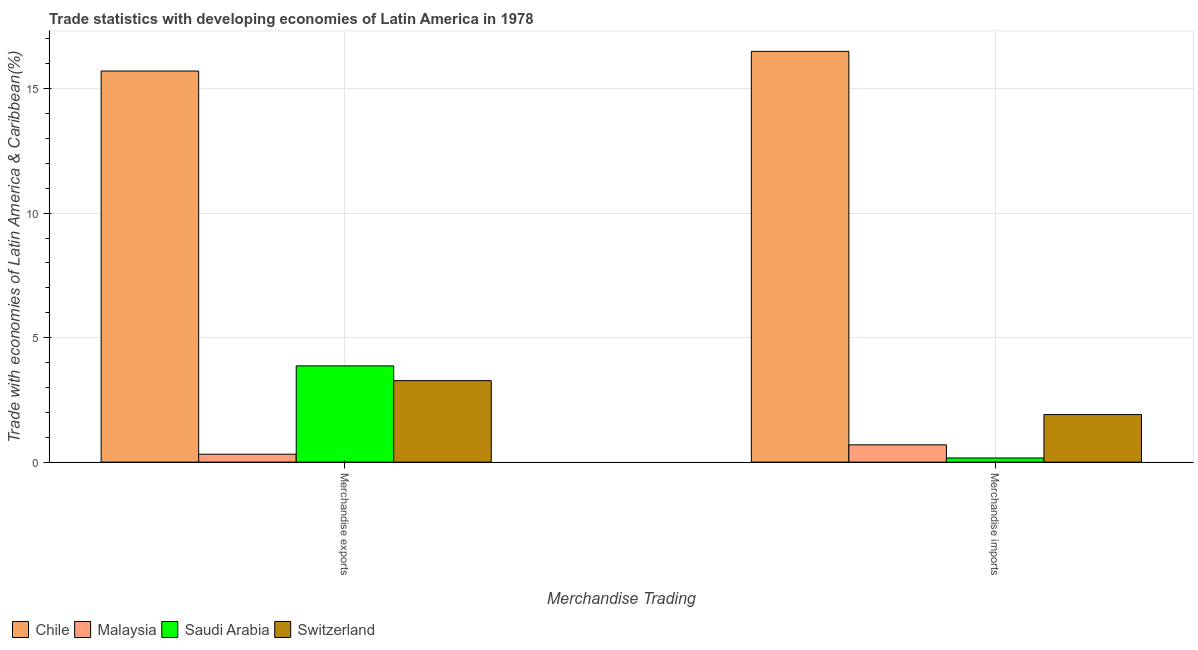How many groups of bars are there?
Your response must be concise. 2. Are the number of bars on each tick of the X-axis equal?
Give a very brief answer. Yes. What is the label of the 1st group of bars from the left?
Your response must be concise. Merchandise exports. What is the merchandise imports in Switzerland?
Offer a very short reply. 1.91. Across all countries, what is the maximum merchandise exports?
Your response must be concise. 15.71. Across all countries, what is the minimum merchandise imports?
Offer a very short reply. 0.17. In which country was the merchandise exports maximum?
Offer a terse response. Chile. In which country was the merchandise imports minimum?
Your answer should be compact. Saudi Arabia. What is the total merchandise exports in the graph?
Ensure brevity in your answer.  23.16. What is the difference between the merchandise imports in Malaysia and that in Saudi Arabia?
Offer a terse response. 0.53. What is the difference between the merchandise exports in Saudi Arabia and the merchandise imports in Switzerland?
Offer a terse response. 1.96. What is the average merchandise exports per country?
Provide a short and direct response. 5.79. What is the difference between the merchandise exports and merchandise imports in Saudi Arabia?
Give a very brief answer. 3.7. In how many countries, is the merchandise imports greater than 10 %?
Keep it short and to the point. 1. What is the ratio of the merchandise imports in Malaysia to that in Switzerland?
Keep it short and to the point. 0.36. In how many countries, is the merchandise exports greater than the average merchandise exports taken over all countries?
Ensure brevity in your answer.  1. What does the 4th bar from the left in Merchandise exports represents?
Make the answer very short. Switzerland. What does the 1st bar from the right in Merchandise imports represents?
Your answer should be very brief. Switzerland. How many bars are there?
Your answer should be compact. 8. Are all the bars in the graph horizontal?
Give a very brief answer. No. Where does the legend appear in the graph?
Offer a terse response. Bottom left. How many legend labels are there?
Ensure brevity in your answer.  4. How are the legend labels stacked?
Keep it short and to the point. Horizontal. What is the title of the graph?
Provide a short and direct response. Trade statistics with developing economies of Latin America in 1978. Does "Seychelles" appear as one of the legend labels in the graph?
Keep it short and to the point. No. What is the label or title of the X-axis?
Your answer should be compact. Merchandise Trading. What is the label or title of the Y-axis?
Make the answer very short. Trade with economies of Latin America & Caribbean(%). What is the Trade with economies of Latin America & Caribbean(%) in Chile in Merchandise exports?
Provide a short and direct response. 15.71. What is the Trade with economies of Latin America & Caribbean(%) in Malaysia in Merchandise exports?
Provide a succinct answer. 0.32. What is the Trade with economies of Latin America & Caribbean(%) in Saudi Arabia in Merchandise exports?
Ensure brevity in your answer.  3.87. What is the Trade with economies of Latin America & Caribbean(%) of Switzerland in Merchandise exports?
Offer a very short reply. 3.27. What is the Trade with economies of Latin America & Caribbean(%) in Chile in Merchandise imports?
Provide a succinct answer. 16.5. What is the Trade with economies of Latin America & Caribbean(%) in Malaysia in Merchandise imports?
Provide a succinct answer. 0.69. What is the Trade with economies of Latin America & Caribbean(%) of Saudi Arabia in Merchandise imports?
Your answer should be compact. 0.17. What is the Trade with economies of Latin America & Caribbean(%) of Switzerland in Merchandise imports?
Provide a succinct answer. 1.91. Across all Merchandise Trading, what is the maximum Trade with economies of Latin America & Caribbean(%) of Chile?
Provide a short and direct response. 16.5. Across all Merchandise Trading, what is the maximum Trade with economies of Latin America & Caribbean(%) in Malaysia?
Make the answer very short. 0.69. Across all Merchandise Trading, what is the maximum Trade with economies of Latin America & Caribbean(%) in Saudi Arabia?
Provide a succinct answer. 3.87. Across all Merchandise Trading, what is the maximum Trade with economies of Latin America & Caribbean(%) in Switzerland?
Offer a very short reply. 3.27. Across all Merchandise Trading, what is the minimum Trade with economies of Latin America & Caribbean(%) of Chile?
Ensure brevity in your answer.  15.71. Across all Merchandise Trading, what is the minimum Trade with economies of Latin America & Caribbean(%) in Malaysia?
Keep it short and to the point. 0.32. Across all Merchandise Trading, what is the minimum Trade with economies of Latin America & Caribbean(%) in Saudi Arabia?
Your answer should be very brief. 0.17. Across all Merchandise Trading, what is the minimum Trade with economies of Latin America & Caribbean(%) of Switzerland?
Ensure brevity in your answer.  1.91. What is the total Trade with economies of Latin America & Caribbean(%) of Chile in the graph?
Offer a very short reply. 32.2. What is the total Trade with economies of Latin America & Caribbean(%) of Malaysia in the graph?
Offer a very short reply. 1.01. What is the total Trade with economies of Latin America & Caribbean(%) in Saudi Arabia in the graph?
Provide a short and direct response. 4.03. What is the total Trade with economies of Latin America & Caribbean(%) in Switzerland in the graph?
Offer a terse response. 5.18. What is the difference between the Trade with economies of Latin America & Caribbean(%) in Chile in Merchandise exports and that in Merchandise imports?
Ensure brevity in your answer.  -0.79. What is the difference between the Trade with economies of Latin America & Caribbean(%) of Malaysia in Merchandise exports and that in Merchandise imports?
Offer a very short reply. -0.38. What is the difference between the Trade with economies of Latin America & Caribbean(%) of Saudi Arabia in Merchandise exports and that in Merchandise imports?
Provide a succinct answer. 3.7. What is the difference between the Trade with economies of Latin America & Caribbean(%) in Switzerland in Merchandise exports and that in Merchandise imports?
Provide a short and direct response. 1.36. What is the difference between the Trade with economies of Latin America & Caribbean(%) in Chile in Merchandise exports and the Trade with economies of Latin America & Caribbean(%) in Malaysia in Merchandise imports?
Provide a succinct answer. 15.01. What is the difference between the Trade with economies of Latin America & Caribbean(%) in Chile in Merchandise exports and the Trade with economies of Latin America & Caribbean(%) in Saudi Arabia in Merchandise imports?
Give a very brief answer. 15.54. What is the difference between the Trade with economies of Latin America & Caribbean(%) of Chile in Merchandise exports and the Trade with economies of Latin America & Caribbean(%) of Switzerland in Merchandise imports?
Your response must be concise. 13.8. What is the difference between the Trade with economies of Latin America & Caribbean(%) of Malaysia in Merchandise exports and the Trade with economies of Latin America & Caribbean(%) of Saudi Arabia in Merchandise imports?
Your response must be concise. 0.15. What is the difference between the Trade with economies of Latin America & Caribbean(%) in Malaysia in Merchandise exports and the Trade with economies of Latin America & Caribbean(%) in Switzerland in Merchandise imports?
Give a very brief answer. -1.59. What is the difference between the Trade with economies of Latin America & Caribbean(%) in Saudi Arabia in Merchandise exports and the Trade with economies of Latin America & Caribbean(%) in Switzerland in Merchandise imports?
Ensure brevity in your answer.  1.96. What is the average Trade with economies of Latin America & Caribbean(%) of Chile per Merchandise Trading?
Give a very brief answer. 16.1. What is the average Trade with economies of Latin America & Caribbean(%) in Malaysia per Merchandise Trading?
Give a very brief answer. 0.51. What is the average Trade with economies of Latin America & Caribbean(%) in Saudi Arabia per Merchandise Trading?
Offer a very short reply. 2.02. What is the average Trade with economies of Latin America & Caribbean(%) of Switzerland per Merchandise Trading?
Offer a very short reply. 2.59. What is the difference between the Trade with economies of Latin America & Caribbean(%) in Chile and Trade with economies of Latin America & Caribbean(%) in Malaysia in Merchandise exports?
Your response must be concise. 15.39. What is the difference between the Trade with economies of Latin America & Caribbean(%) in Chile and Trade with economies of Latin America & Caribbean(%) in Saudi Arabia in Merchandise exports?
Give a very brief answer. 11.84. What is the difference between the Trade with economies of Latin America & Caribbean(%) in Chile and Trade with economies of Latin America & Caribbean(%) in Switzerland in Merchandise exports?
Provide a short and direct response. 12.44. What is the difference between the Trade with economies of Latin America & Caribbean(%) of Malaysia and Trade with economies of Latin America & Caribbean(%) of Saudi Arabia in Merchandise exports?
Your response must be concise. -3.55. What is the difference between the Trade with economies of Latin America & Caribbean(%) of Malaysia and Trade with economies of Latin America & Caribbean(%) of Switzerland in Merchandise exports?
Ensure brevity in your answer.  -2.95. What is the difference between the Trade with economies of Latin America & Caribbean(%) in Saudi Arabia and Trade with economies of Latin America & Caribbean(%) in Switzerland in Merchandise exports?
Ensure brevity in your answer.  0.59. What is the difference between the Trade with economies of Latin America & Caribbean(%) of Chile and Trade with economies of Latin America & Caribbean(%) of Malaysia in Merchandise imports?
Your answer should be compact. 15.8. What is the difference between the Trade with economies of Latin America & Caribbean(%) of Chile and Trade with economies of Latin America & Caribbean(%) of Saudi Arabia in Merchandise imports?
Make the answer very short. 16.33. What is the difference between the Trade with economies of Latin America & Caribbean(%) in Chile and Trade with economies of Latin America & Caribbean(%) in Switzerland in Merchandise imports?
Offer a terse response. 14.59. What is the difference between the Trade with economies of Latin America & Caribbean(%) of Malaysia and Trade with economies of Latin America & Caribbean(%) of Saudi Arabia in Merchandise imports?
Provide a succinct answer. 0.53. What is the difference between the Trade with economies of Latin America & Caribbean(%) of Malaysia and Trade with economies of Latin America & Caribbean(%) of Switzerland in Merchandise imports?
Ensure brevity in your answer.  -1.22. What is the difference between the Trade with economies of Latin America & Caribbean(%) in Saudi Arabia and Trade with economies of Latin America & Caribbean(%) in Switzerland in Merchandise imports?
Offer a terse response. -1.74. What is the ratio of the Trade with economies of Latin America & Caribbean(%) of Chile in Merchandise exports to that in Merchandise imports?
Ensure brevity in your answer.  0.95. What is the ratio of the Trade with economies of Latin America & Caribbean(%) in Malaysia in Merchandise exports to that in Merchandise imports?
Your answer should be compact. 0.46. What is the ratio of the Trade with economies of Latin America & Caribbean(%) of Saudi Arabia in Merchandise exports to that in Merchandise imports?
Offer a terse response. 23.2. What is the ratio of the Trade with economies of Latin America & Caribbean(%) of Switzerland in Merchandise exports to that in Merchandise imports?
Your answer should be compact. 1.71. What is the difference between the highest and the second highest Trade with economies of Latin America & Caribbean(%) of Chile?
Provide a short and direct response. 0.79. What is the difference between the highest and the second highest Trade with economies of Latin America & Caribbean(%) of Malaysia?
Offer a very short reply. 0.38. What is the difference between the highest and the second highest Trade with economies of Latin America & Caribbean(%) in Saudi Arabia?
Your response must be concise. 3.7. What is the difference between the highest and the second highest Trade with economies of Latin America & Caribbean(%) of Switzerland?
Your response must be concise. 1.36. What is the difference between the highest and the lowest Trade with economies of Latin America & Caribbean(%) in Chile?
Give a very brief answer. 0.79. What is the difference between the highest and the lowest Trade with economies of Latin America & Caribbean(%) in Malaysia?
Offer a very short reply. 0.38. What is the difference between the highest and the lowest Trade with economies of Latin America & Caribbean(%) in Saudi Arabia?
Your answer should be compact. 3.7. What is the difference between the highest and the lowest Trade with economies of Latin America & Caribbean(%) of Switzerland?
Your response must be concise. 1.36. 